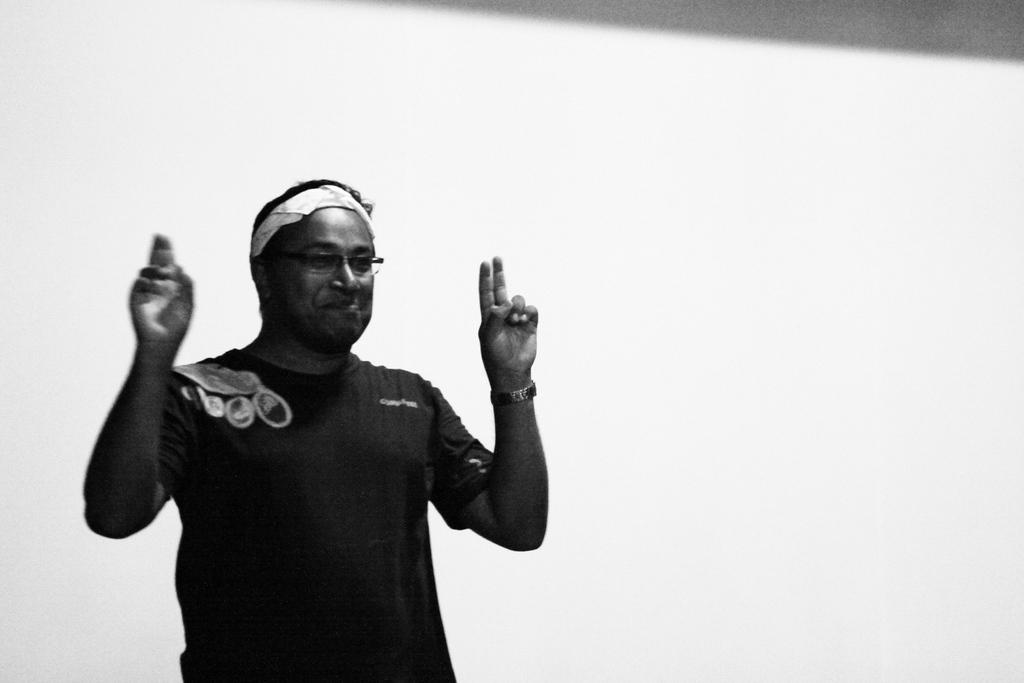What is the main subject of the image? There is a person in the image. What is the color of the background in the image? The background of the image is white. What type of structure can be seen in the background of the image during the thunderstorm? There is no structure or thunderstorm present in the image; it features a person against a white background. 